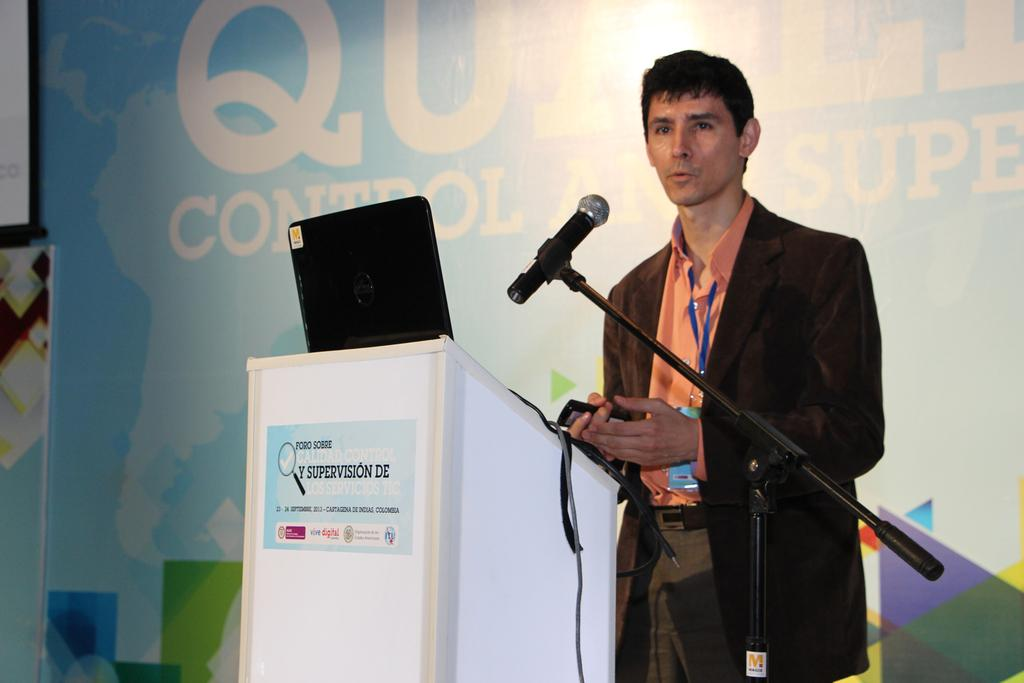What is the main object on the podium in the image? There is a laptop on the podium in the image. What is the person near the podium doing? The person is standing near the podium and holding a microphone. Can you describe the setting of the image? The image shows a podium with a laptop and a person holding a microphone. What type of furniture is being traded in the image? There is no furniture or trade activity depicted in the image. Can you see a hose connected to the laptop in the image? No, there is no hose connected to the laptop in the image. 